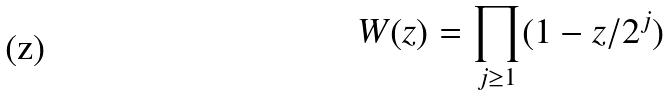Convert formula to latex. <formula><loc_0><loc_0><loc_500><loc_500>W ( z ) = \prod _ { j \geq 1 } ( 1 - z / 2 ^ { j } )</formula> 